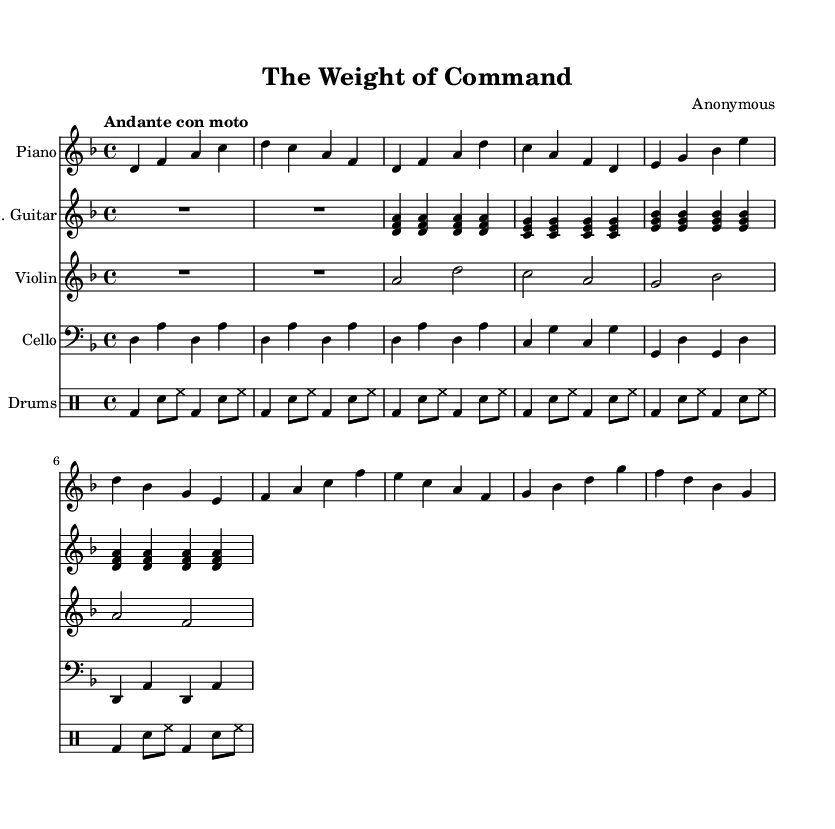What is the key signature of this music? The key signature can be found at the beginning of the staff, indicating the note D is sharp or flat; the music is in D minor, which has one flat (B flat).
Answer: D minor What is the time signature of this piece? The time signature is shown at the beginning of the score; the notation "4/4" indicates that there are four beats in a measure, and the quarter note gets one beat.
Answer: 4/4 What is the tempo marking given for this piece? The tempo marking is typically found above the music staff; "Andante con moto" indicates a moderately slow tempo with some motion.
Answer: Andante con moto How many measures are in the piano part? By counting the segments divided by vertical lines in the piano staff, there are eight measures in total, which is standard for this section of the score.
Answer: Eight What instrument plays the lowest range? By observing the clefs used, the cello is written in bass clef and generally plays lower than the other instruments in this score.
Answer: Cello Which instrument has the most rhythmic variation represented? The drum part shows different rhythms and subdivisions within measures, indicating a high level of variation compared to other instruments.
Answer: Drums 